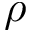<formula> <loc_0><loc_0><loc_500><loc_500>\rho</formula> 